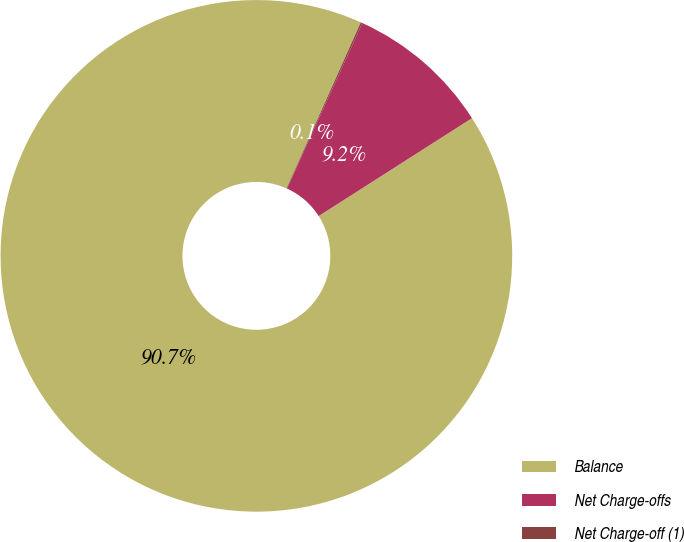Convert chart to OTSL. <chart><loc_0><loc_0><loc_500><loc_500><pie_chart><fcel>Balance<fcel>Net Charge-offs<fcel>Net Charge-off (1)<nl><fcel>90.73%<fcel>9.16%<fcel>0.1%<nl></chart> 